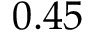<formula> <loc_0><loc_0><loc_500><loc_500>0 . 4 5</formula> 